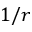Convert formula to latex. <formula><loc_0><loc_0><loc_500><loc_500>1 / r</formula> 